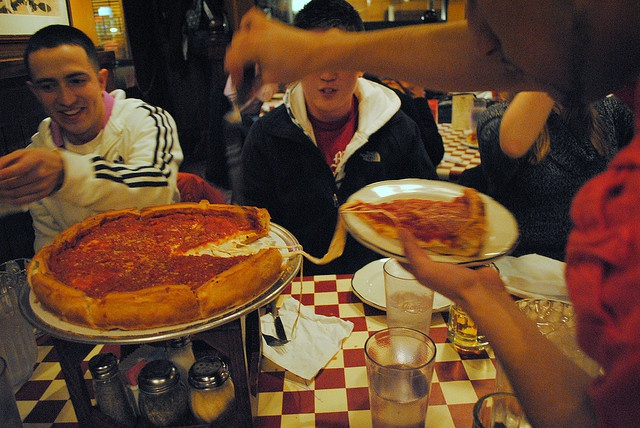Describe the objects in this image and their specific colors. I can see people in black, maroon, and brown tones, dining table in black, olive, maroon, and tan tones, people in black, olive, and maroon tones, people in black, maroon, brown, and beige tones, and pizza in black, brown, maroon, and red tones in this image. 